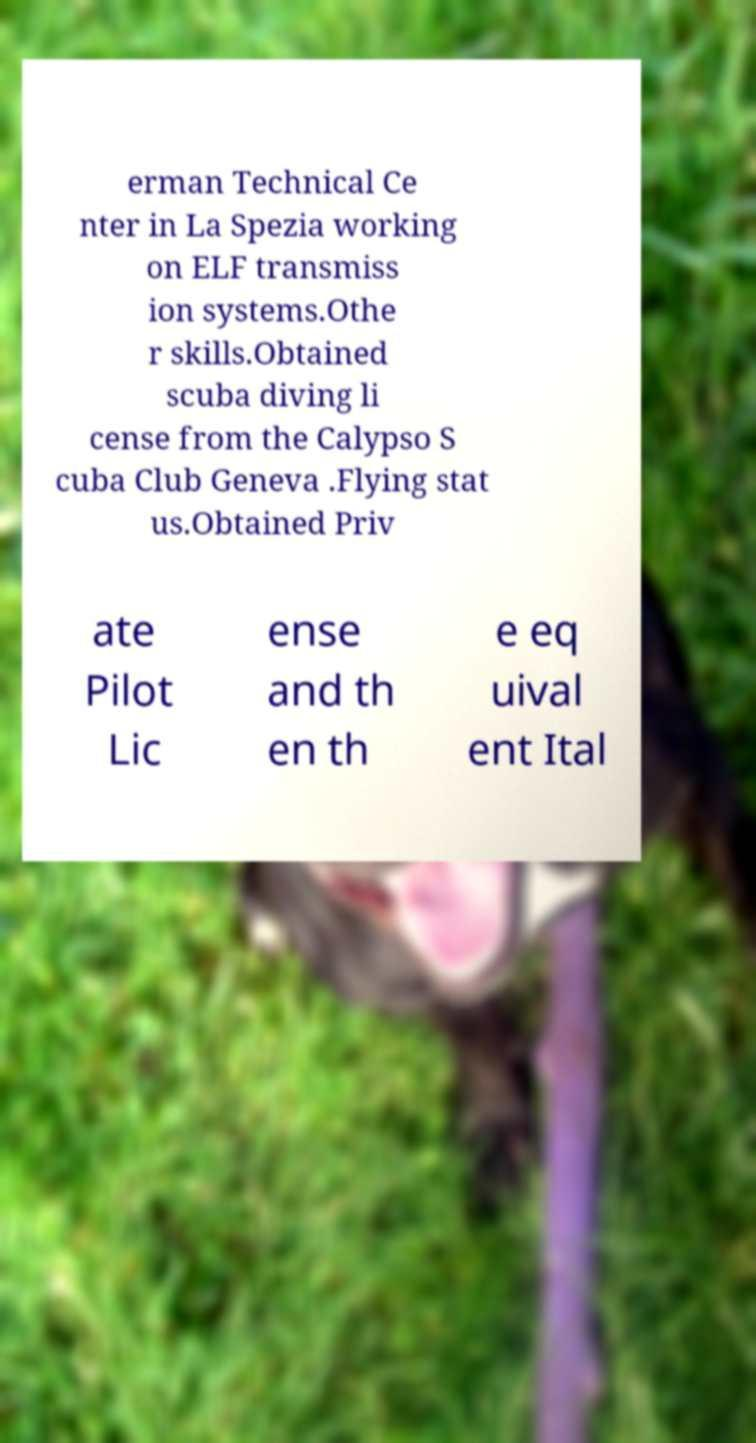Could you extract and type out the text from this image? erman Technical Ce nter in La Spezia working on ELF transmiss ion systems.Othe r skills.Obtained scuba diving li cense from the Calypso S cuba Club Geneva .Flying stat us.Obtained Priv ate Pilot Lic ense and th en th e eq uival ent Ital 